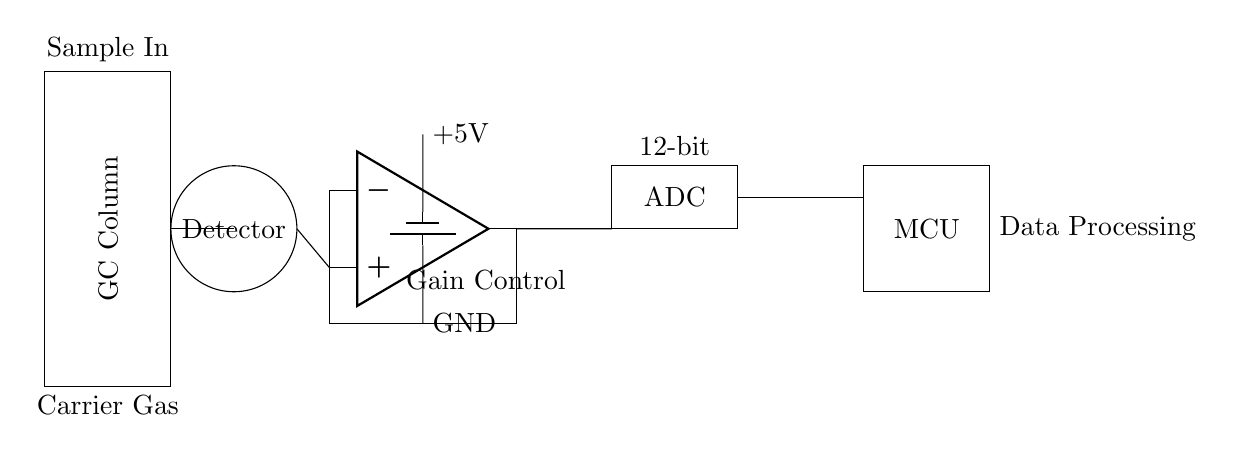What is the main component responsible for detecting volatile compounds? The main component responsible for detecting volatile compounds is labeled as the "Detector" in the circuit diagram. This is explicitly stated within the circular representation of the component.
Answer: Detector What type of power supply is used in this circuit? The power supply used in this circuit is a battery, as indicated by the symbol for a battery on the circuit. The voltage levels are specified as +5V and ground beneath the corresponding connections.
Answer: Battery How many bits does the Analog-to-Digital Converter (ADC) have? The ADC in the circuit is labeled as having 12 bits, which is directly stated next to the ADC component rectangle.
Answer: 12-bit What component amplifies the signal from the detector? The component that amplifies the signal from the detector is an operational amplifier (op amp), represented by the triangular symbol. It is connected to the detector and appears before the ADC in the signal pathway.
Answer: Operational amplifier What is the role of the microcontroller (MCU) in this circuit? The role of the microcontroller (MCU) is to process the data received from the ADC. This is inferred from the labeling "Data Processing" next to the MCU and its position in the signal flow after the ADC.
Answer: Data Processing What is the significance of the gain control in this circuit? Gain control is significant in this circuit as it allows for adjusting the amplification level of the signal coming from the detector through the operational amplifier. This is indicated by the label "Gain Control" next to the op amp, which represents a key parameter for optimizing detector performance.
Answer: Adjusting signal amplification 